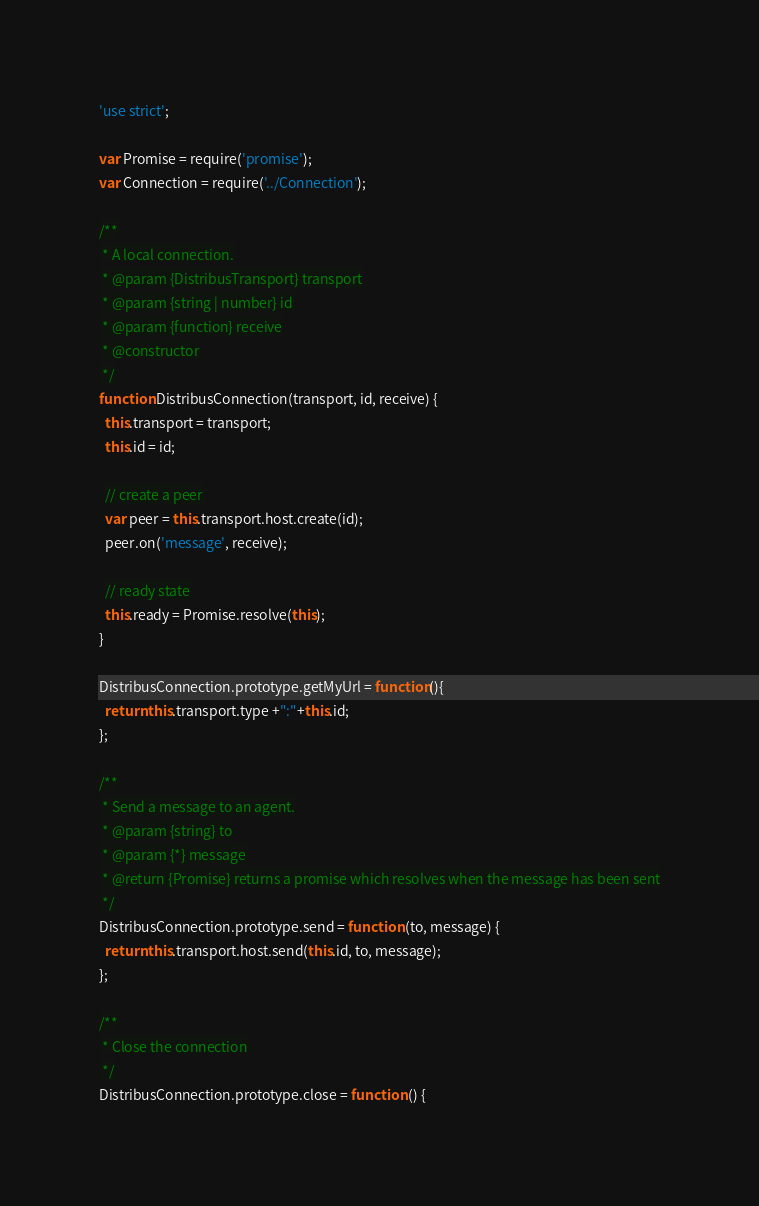<code> <loc_0><loc_0><loc_500><loc_500><_JavaScript_>'use strict';

var Promise = require('promise');
var Connection = require('../Connection');

/**
 * A local connection.
 * @param {DistribusTransport} transport
 * @param {string | number} id
 * @param {function} receive
 * @constructor
 */
function DistribusConnection(transport, id, receive) {
  this.transport = transport;
  this.id = id;

  // create a peer
  var peer = this.transport.host.create(id);
  peer.on('message', receive);

  // ready state
  this.ready = Promise.resolve(this);
}

DistribusConnection.prototype.getMyUrl = function(){
  return this.transport.type +":"+this.id;
};

/**
 * Send a message to an agent.
 * @param {string} to
 * @param {*} message
 * @return {Promise} returns a promise which resolves when the message has been sent
 */
DistribusConnection.prototype.send = function (to, message) {
  return this.transport.host.send(this.id, to, message);
};

/**
 * Close the connection
 */
DistribusConnection.prototype.close = function () {</code> 